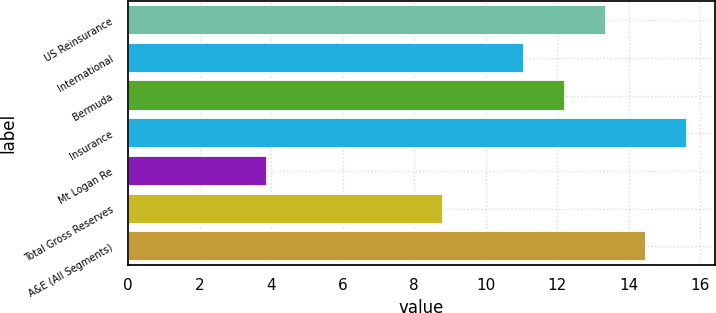<chart> <loc_0><loc_0><loc_500><loc_500><bar_chart><fcel>US Reinsurance<fcel>International<fcel>Bermuda<fcel>Insurance<fcel>Mt Logan Re<fcel>Total Gross Reserves<fcel>A&E (All Segments)<nl><fcel>13.36<fcel>11.08<fcel>12.22<fcel>15.64<fcel>3.87<fcel>8.8<fcel>14.5<nl></chart> 